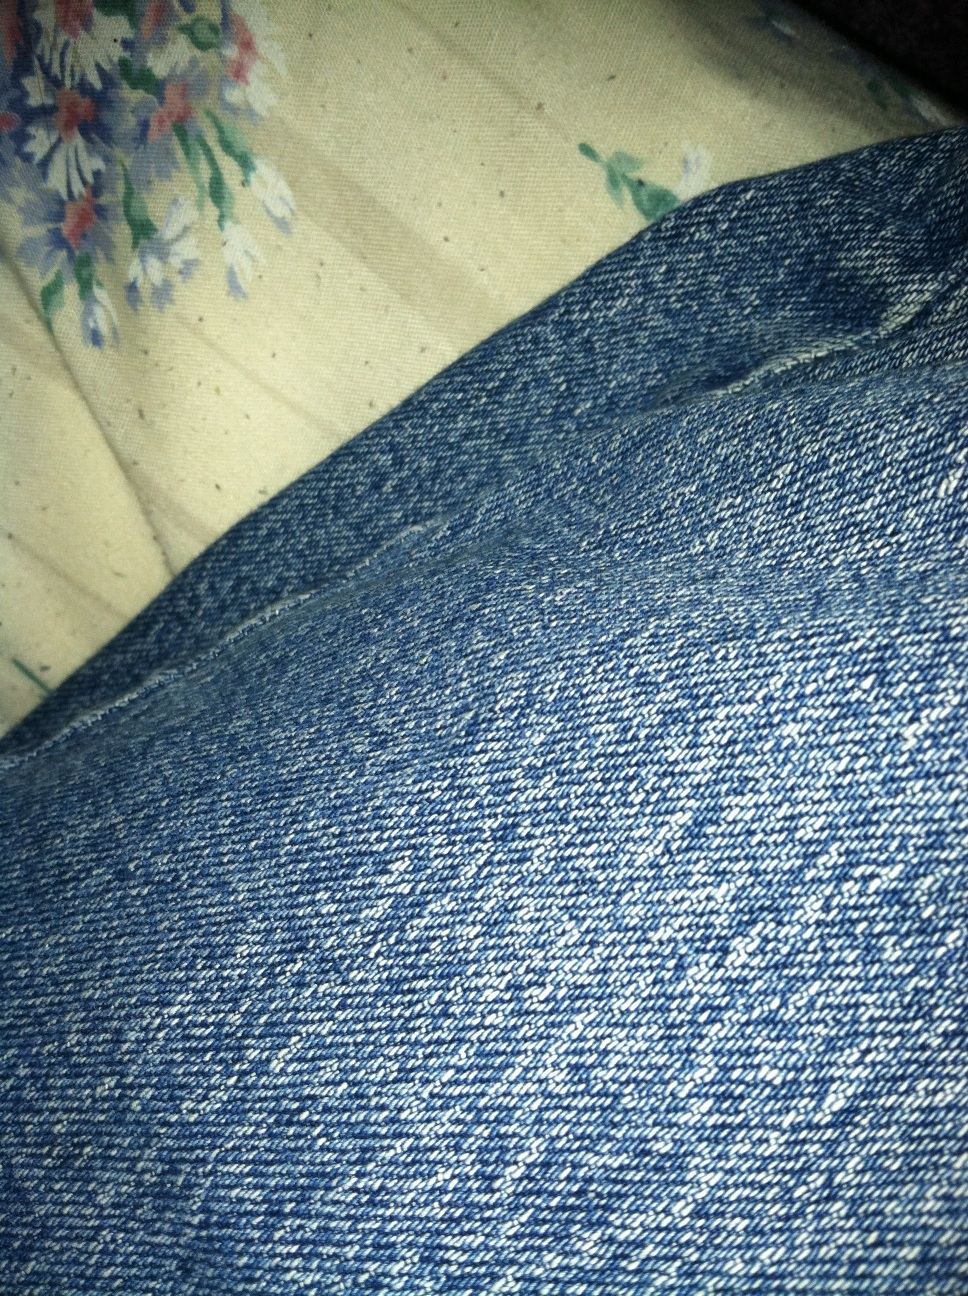What color are these jeans? The jeans in the image are a classic blue color, showcasing the well-known denim texture and weave pattern typically associated with this type of fabric. 